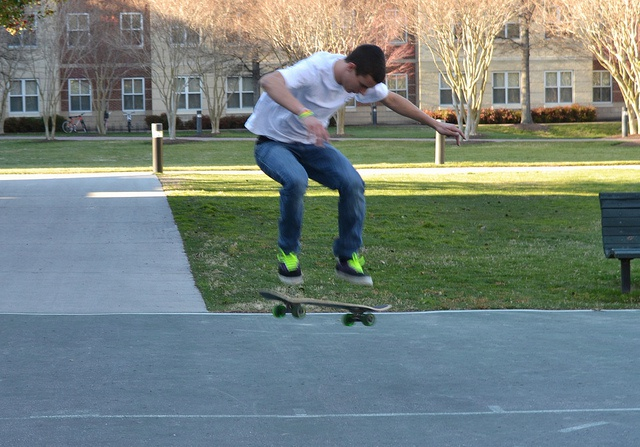Describe the objects in this image and their specific colors. I can see people in black, gray, and darkgray tones, bench in black, darkblue, blue, and teal tones, skateboard in black, gray, darkgray, and teal tones, and bicycle in black, gray, and darkblue tones in this image. 